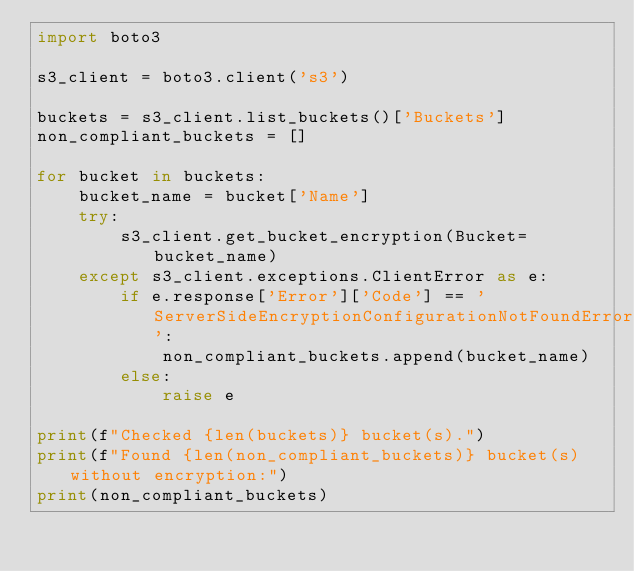Convert code to text. <code><loc_0><loc_0><loc_500><loc_500><_Python_>import boto3

s3_client = boto3.client('s3')

buckets = s3_client.list_buckets()['Buckets']
non_compliant_buckets = []

for bucket in buckets:
    bucket_name = bucket['Name']
    try:
        s3_client.get_bucket_encryption(Bucket=bucket_name)
    except s3_client.exceptions.ClientError as e:
        if e.response['Error']['Code'] == 'ServerSideEncryptionConfigurationNotFoundError':
            non_compliant_buckets.append(bucket_name)
        else:
            raise e

print(f"Checked {len(buckets)} bucket(s).")
print(f"Found {len(non_compliant_buckets)} bucket(s) without encryption:")
print(non_compliant_buckets)
</code> 